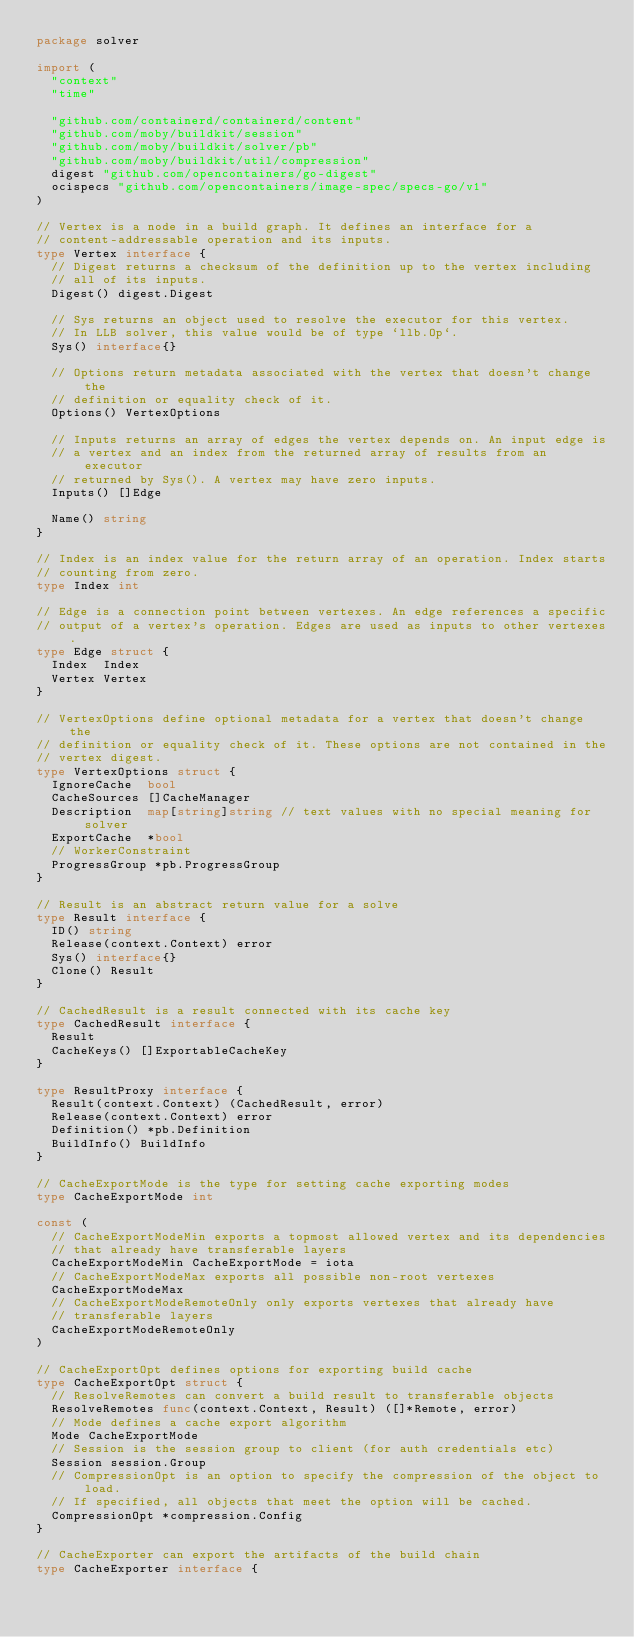Convert code to text. <code><loc_0><loc_0><loc_500><loc_500><_Go_>package solver

import (
	"context"
	"time"

	"github.com/containerd/containerd/content"
	"github.com/moby/buildkit/session"
	"github.com/moby/buildkit/solver/pb"
	"github.com/moby/buildkit/util/compression"
	digest "github.com/opencontainers/go-digest"
	ocispecs "github.com/opencontainers/image-spec/specs-go/v1"
)

// Vertex is a node in a build graph. It defines an interface for a
// content-addressable operation and its inputs.
type Vertex interface {
	// Digest returns a checksum of the definition up to the vertex including
	// all of its inputs.
	Digest() digest.Digest

	// Sys returns an object used to resolve the executor for this vertex.
	// In LLB solver, this value would be of type `llb.Op`.
	Sys() interface{}

	// Options return metadata associated with the vertex that doesn't change the
	// definition or equality check of it.
	Options() VertexOptions

	// Inputs returns an array of edges the vertex depends on. An input edge is
	// a vertex and an index from the returned array of results from an executor
	// returned by Sys(). A vertex may have zero inputs.
	Inputs() []Edge

	Name() string
}

// Index is an index value for the return array of an operation. Index starts
// counting from zero.
type Index int

// Edge is a connection point between vertexes. An edge references a specific
// output of a vertex's operation. Edges are used as inputs to other vertexes.
type Edge struct {
	Index  Index
	Vertex Vertex
}

// VertexOptions define optional metadata for a vertex that doesn't change the
// definition or equality check of it. These options are not contained in the
// vertex digest.
type VertexOptions struct {
	IgnoreCache  bool
	CacheSources []CacheManager
	Description  map[string]string // text values with no special meaning for solver
	ExportCache  *bool
	// WorkerConstraint
	ProgressGroup *pb.ProgressGroup
}

// Result is an abstract return value for a solve
type Result interface {
	ID() string
	Release(context.Context) error
	Sys() interface{}
	Clone() Result
}

// CachedResult is a result connected with its cache key
type CachedResult interface {
	Result
	CacheKeys() []ExportableCacheKey
}

type ResultProxy interface {
	Result(context.Context) (CachedResult, error)
	Release(context.Context) error
	Definition() *pb.Definition
	BuildInfo() BuildInfo
}

// CacheExportMode is the type for setting cache exporting modes
type CacheExportMode int

const (
	// CacheExportModeMin exports a topmost allowed vertex and its dependencies
	// that already have transferable layers
	CacheExportModeMin CacheExportMode = iota
	// CacheExportModeMax exports all possible non-root vertexes
	CacheExportModeMax
	// CacheExportModeRemoteOnly only exports vertexes that already have
	// transferable layers
	CacheExportModeRemoteOnly
)

// CacheExportOpt defines options for exporting build cache
type CacheExportOpt struct {
	// ResolveRemotes can convert a build result to transferable objects
	ResolveRemotes func(context.Context, Result) ([]*Remote, error)
	// Mode defines a cache export algorithm
	Mode CacheExportMode
	// Session is the session group to client (for auth credentials etc)
	Session session.Group
	// CompressionOpt is an option to specify the compression of the object to load.
	// If specified, all objects that meet the option will be cached.
	CompressionOpt *compression.Config
}

// CacheExporter can export the artifacts of the build chain
type CacheExporter interface {</code> 